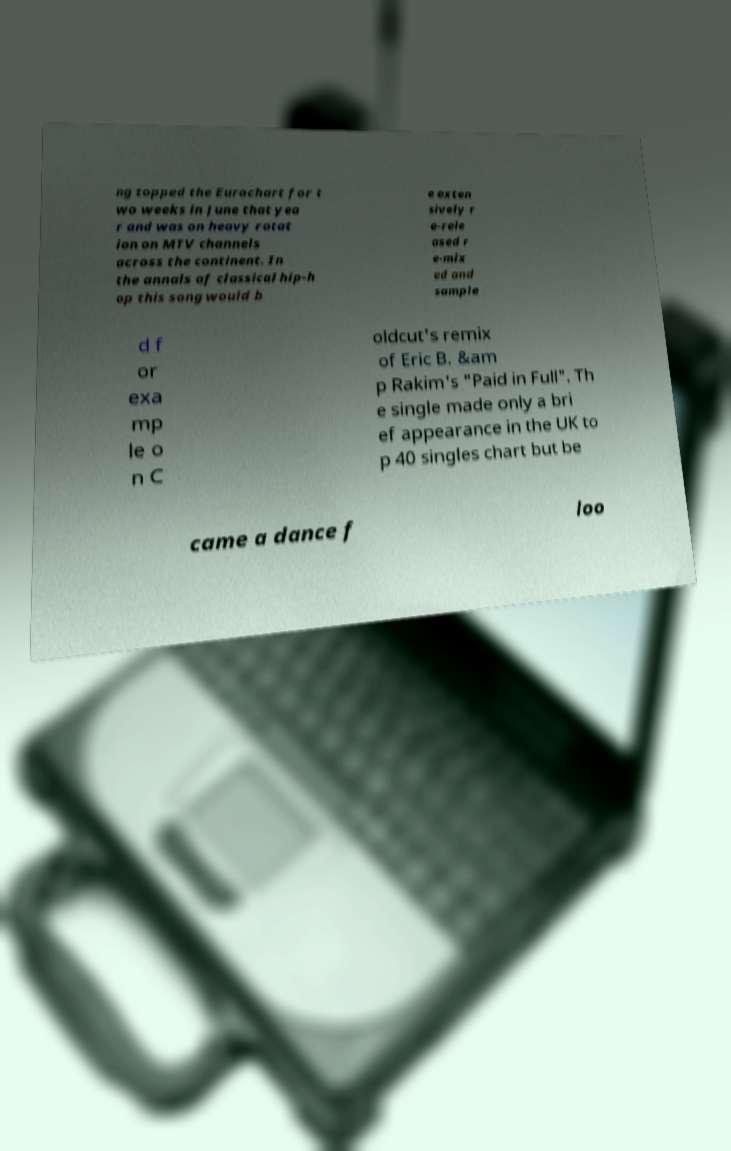Please identify and transcribe the text found in this image. ng topped the Eurochart for t wo weeks in June that yea r and was on heavy rotat ion on MTV channels across the continent. In the annals of classical hip-h op this song would b e exten sively r e-rele ased r e-mix ed and sample d f or exa mp le o n C oldcut's remix of Eric B. &am p Rakim's "Paid in Full". Th e single made only a bri ef appearance in the UK to p 40 singles chart but be came a dance f loo 